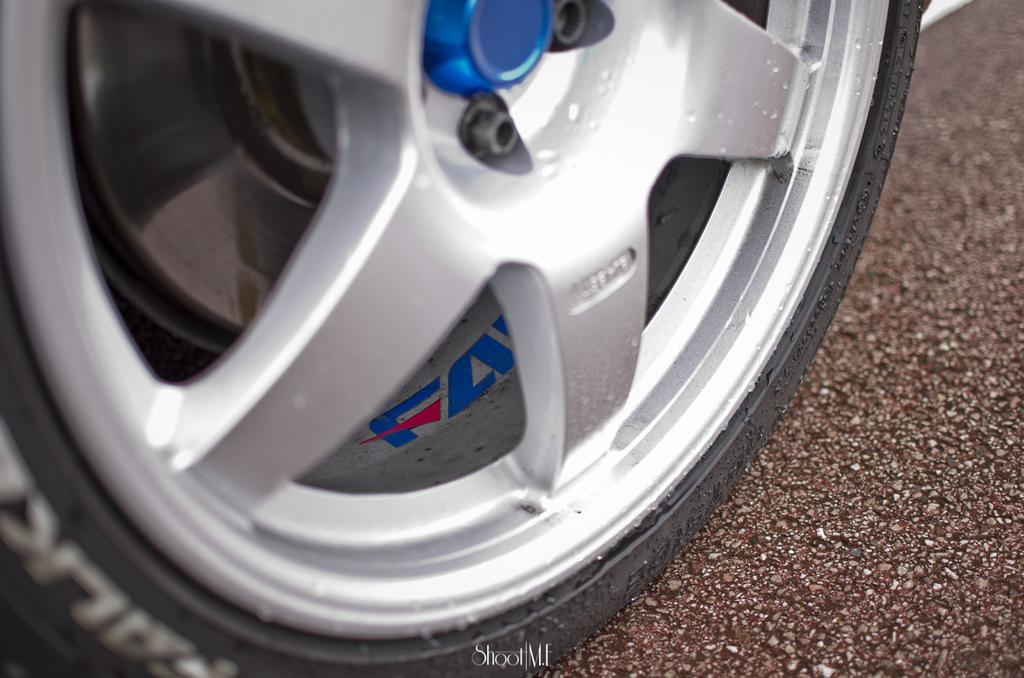How would you summarize this image in a sentence or two? In this image I can see a wheel of a car on the road. This image is taken during a day. 